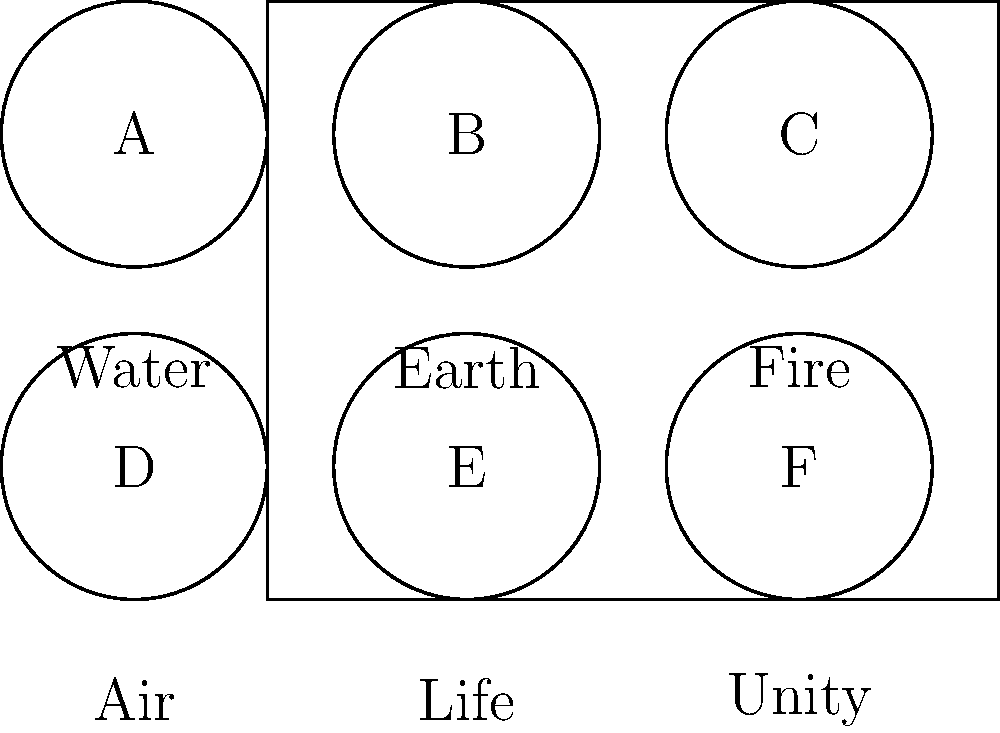Match the indigenous symbols (A-F) with their corresponding meanings in the context of cultural preservation efforts for the Niger Delta region. Which symbol represents "Unity" in this indigenous symbolism? To answer this question, we need to analyze the given diagram and match the symbols with their meanings:

1. The diagram shows six circles labeled A through F.
2. Below each circle, there's a corresponding meaning.
3. We need to identify which symbol is associated with "Unity".

Let's go through each symbol and its meaning:

A - Water
B - Earth
C - Fire
D - Air
E - Life
F - Unity

From this analysis, we can see that the symbol F corresponds to "Unity".

This type of cultural knowledge is crucial for preserving and promoting indigenous heritage in the Niger Delta region. Understanding these symbols helps in:

1. Maintaining traditional knowledge systems
2. Strengthening community identity
3. Educating younger generations about their cultural heritage
4. Promoting cultural diversity and respect for indigenous wisdom

As a local chief advocating for indigenous rights, recognizing and preserving these symbols is an essential part of cultural empowerment and preservation efforts.
Answer: F 